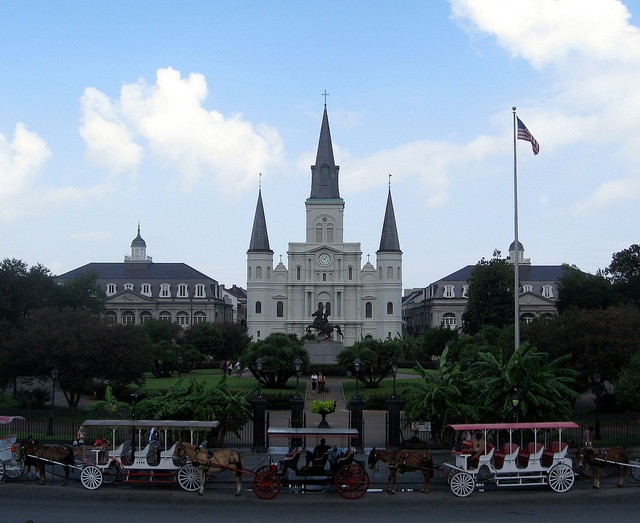Describe the objects in this image and their specific colors. I can see horse in lightblue, black, gray, and darkblue tones, horse in lightblue, black, and gray tones, horse in lightblue, black, gray, and darkgray tones, horse in lightblue, black, gray, and darkgray tones, and people in lightblue, black, darkgreen, and gray tones in this image. 